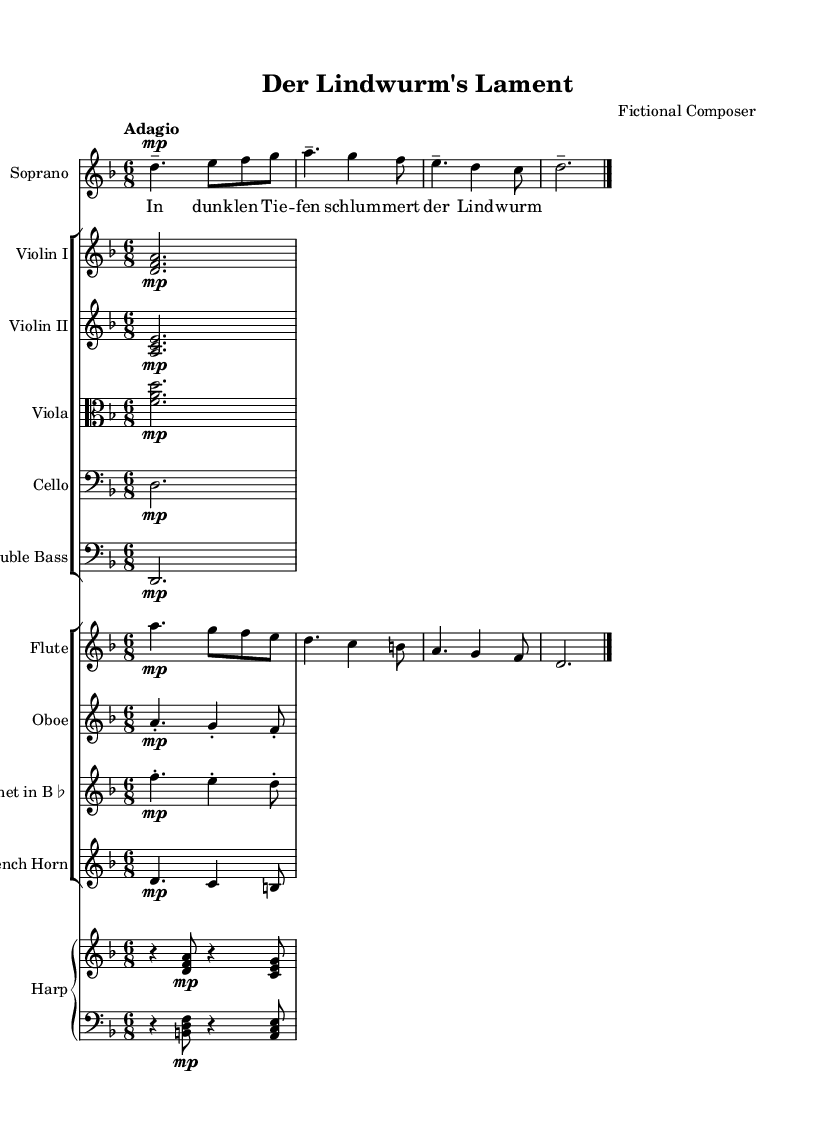What is the key signature of this music? The key signature is D minor, which has one flat (B flat). This indicates that in any part of the music where there is no accidental, the note B should be played as B flat.
Answer: D minor What is the time signature of this music? The time signature is 6/8, which means there are six eighth notes in each measure, creating a compound duple rhythm.
Answer: 6/8 What is the tempo marking of this music? The tempo marking is "Adagio," indicating that the piece should be played slowly. This often evokes a reflective or mournful mood.
Answer: Adagio How many instruments are indicated in the score? The score comprises a total of 10 instruments: Soprano, 2 Violins, Viola, Cello, Double Bass, Flute, Oboe, Clarinet, French Horn, and Harp (with two staves). This creates a rich orchestral texture common in operatic compositions.
Answer: 10 instruments What is the lyrical theme presented by the soprano? The soprano's lyrics emerge from a narrative, speaking of the "Lindwurm," suggesting a mythical creature in a dark and mysterious setting. The text "In dunklen Tiefen schlumert der Lindwurm" translates to "In dark depths slumbers the Lindwurm," indicating a sense of depth and darkness surrounding the creature.
Answer: The Lindwurm What instruments have a dynamic marking of "mp"? The dynamic marking "mp" (mezzo-piano) is indicated for several instruments including Soprano, Violin I, Violin II, Viola, Cello, Double Bass, Flute, Oboe, Clarinet, and French Horn. This marking guides players to perform at a moderately soft volume, maintaining a delicate balance in texture.
Answer: Soprano, Violins, Viola, Cello, Double Bass, Flute, Oboe, Clarinet, French Horn What is the significance of the word "tenuto" in the performance directions? The term "tenuto" instructs the musician to hold the note for its full value or slightly longer, emphasizing it. This technique adds weight to the phrase and is often used in operatic singing to convey emotion.
Answer: Emphasis on sustained notes 